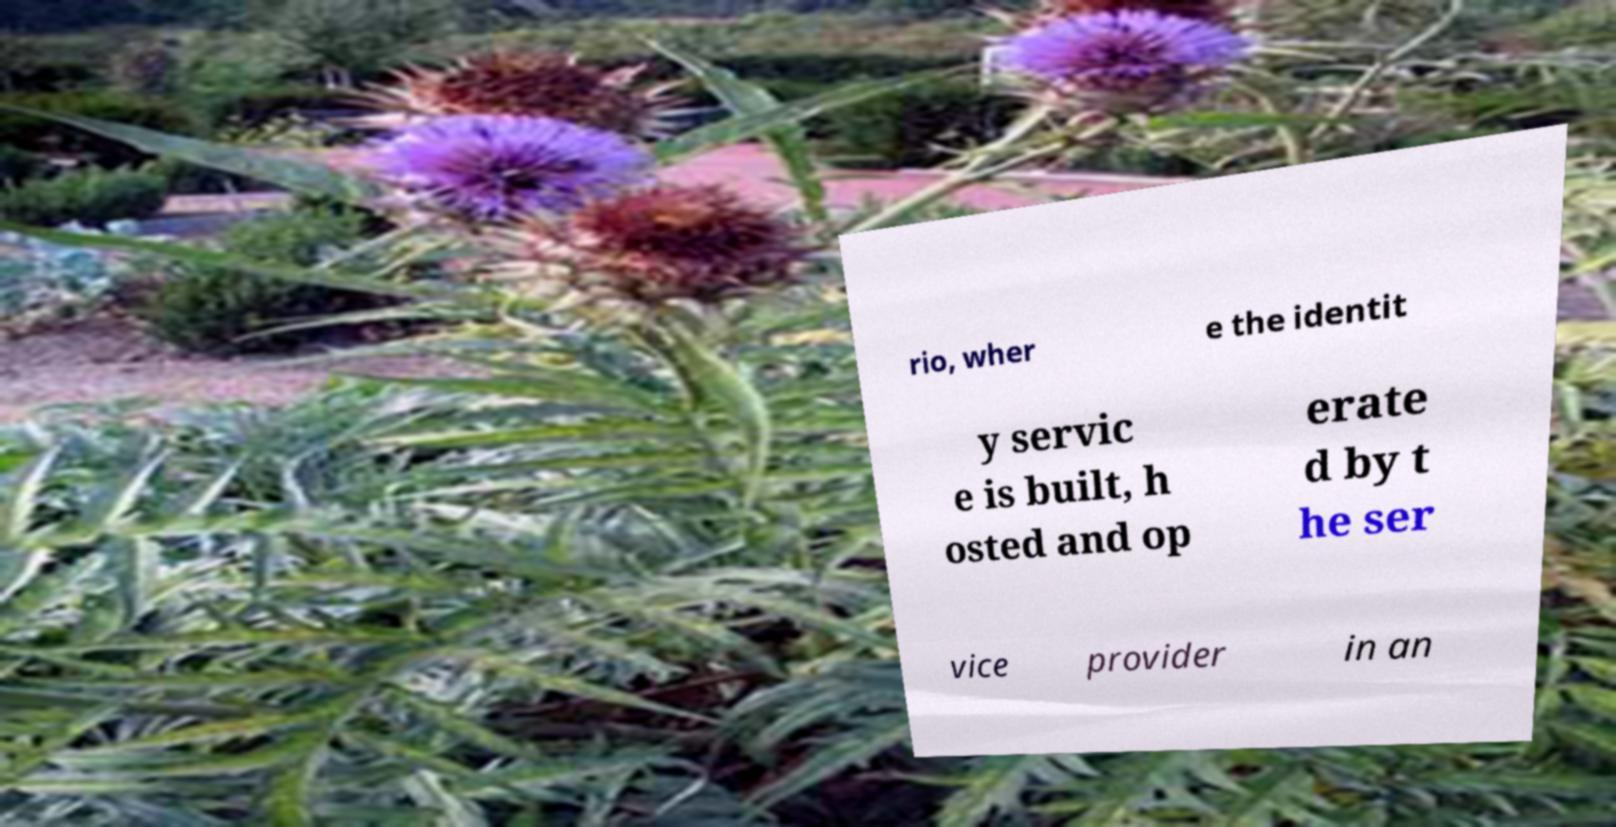There's text embedded in this image that I need extracted. Can you transcribe it verbatim? rio, wher e the identit y servic e is built, h osted and op erate d by t he ser vice provider in an 